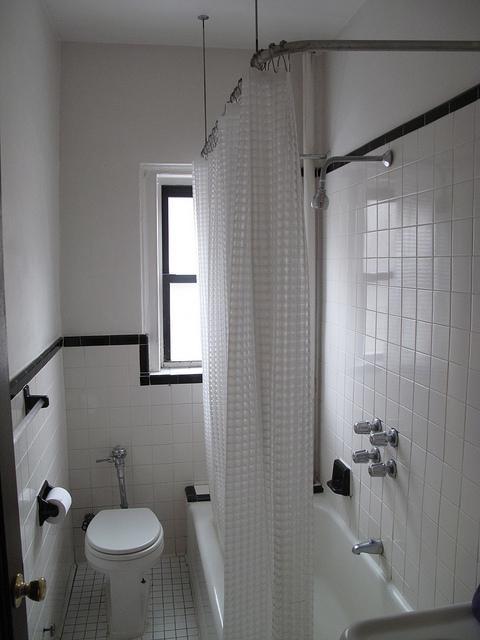How many people are playing tennis?
Give a very brief answer. 0. 